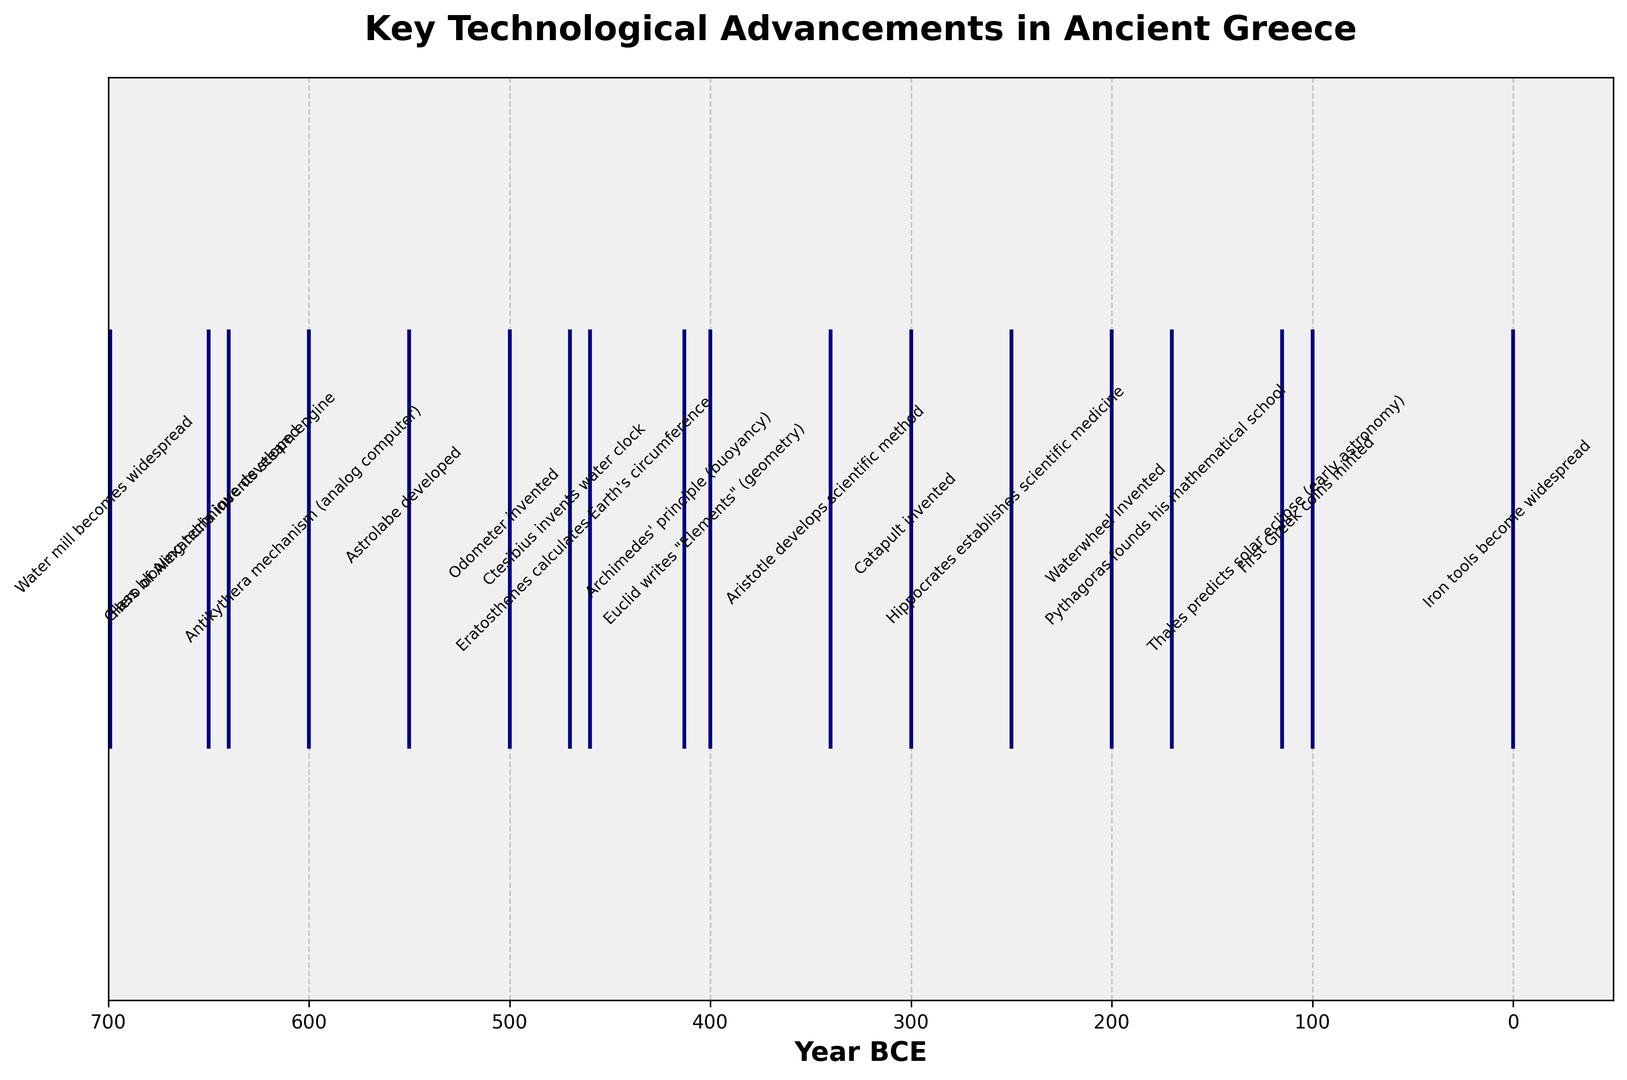What's the earliest technological advancement listed in the figure? By looking at the figure, we can see that the earliest technological advancement is at the furthest left point on the timeline. It corresponds to 700 BCE with the event "Iron tools become widespread".
Answer: 700 BCE Which advancement occurred closer to the birth of Christ: the invention of the steam engine or glass blowing technique? The steam engine invention by Hero of Alexandria is plotted around 60 BCE, whereas the glass blowing technique developed closer to 50 BCE. Thus, glass blowing technique occurred closer to the birth of Christ.
Answer: Glass blowing technique How many years after the invention of the water clock was the odometer invented? The water clock was invented around 230 BCE, and the odometer around 200 BCE. The difference in years is 230 - 200 = 30 years.
Answer: 30 years Did the development of scientific medicine by Hippocrates happen before or after Aristotle developed the scientific method? The development of scientific medicine by Hippocrates occurred around 450 BCE, while Aristotle developed the scientific method around 360 BCE. Thus, Hippocrates' contribution happened before Aristotle's.
Answer: Before What is the time span between the prediction of the solar eclipse by Thales and Euclid writing "Elements"? Thales predicted a solar eclipse around 585 BCE; Euclid wrote "Elements" around 300 BCE. The time span between these events is 585 - 300 = 285 years.
Answer: 285 years Which event is closer to the invention of the astrolabe: the invention of the analog computer (Antikythera mechanism) or the invention of the odometer? The astrolabe was developed around 150 BCE. The Antikythera mechanism was invented around 100 BCE, which is just 50 years later. The odometer was invented around 200 BCE, which is 50 years earlier than the astrolabe. Since both are equidistant, both events are equally close to the invention of the astrolabe.
Answer: Both are equally close How long after Thales' prediction of a solar eclipse was the watermill widespread? Thales predicted the solar eclipse around 585 BCE. The watermill became widespread around 1 BCE. The time difference is 585 - 1 = 584 years.
Answer: 584 years Which technological advancement is positioned exactly in the middle between the prediction of the solar eclipse by Thales and the invention of the astrolabe? Thales' prediction happened around 585 BCE and the astrolabe was developed around 150 BCE. The middle point is (585 + 150) / 2 = 367.5 which rounds to 368. Around 368 BCE, Aristotle developed the scientific method, which was marked around 360 BCE.
Answer: Aristotle developed the scientific method How does the frequency of technological advancements in the 6th century BCE (600-500 BCE) compare to the 2nd century BCE (200-100 BCE)? In the 6th century BCE, there were three advancements: the first Greek coins were minted (600 BCE), Thales predicted a solar eclipse (585 BCE), and Pythagoras founded his mathematical school (530 BCE). In the 2nd century BCE, there were four advancements: the odometer (200 BCE), the astrolabe (150 BCE), the Antikythera mechanism (100 BCE), and Hero of Alexandria's steam engine (60 BCE). Hence, the 2nd century BCE had more advancements.
Answer: 2nd century BCE had more advancements 